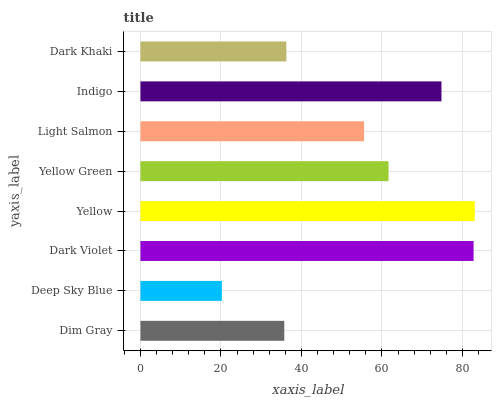Is Deep Sky Blue the minimum?
Answer yes or no. Yes. Is Yellow the maximum?
Answer yes or no. Yes. Is Dark Violet the minimum?
Answer yes or no. No. Is Dark Violet the maximum?
Answer yes or no. No. Is Dark Violet greater than Deep Sky Blue?
Answer yes or no. Yes. Is Deep Sky Blue less than Dark Violet?
Answer yes or no. Yes. Is Deep Sky Blue greater than Dark Violet?
Answer yes or no. No. Is Dark Violet less than Deep Sky Blue?
Answer yes or no. No. Is Yellow Green the high median?
Answer yes or no. Yes. Is Light Salmon the low median?
Answer yes or no. Yes. Is Yellow the high median?
Answer yes or no. No. Is Indigo the low median?
Answer yes or no. No. 